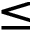<formula> <loc_0><loc_0><loc_500><loc_500>\leq</formula> 